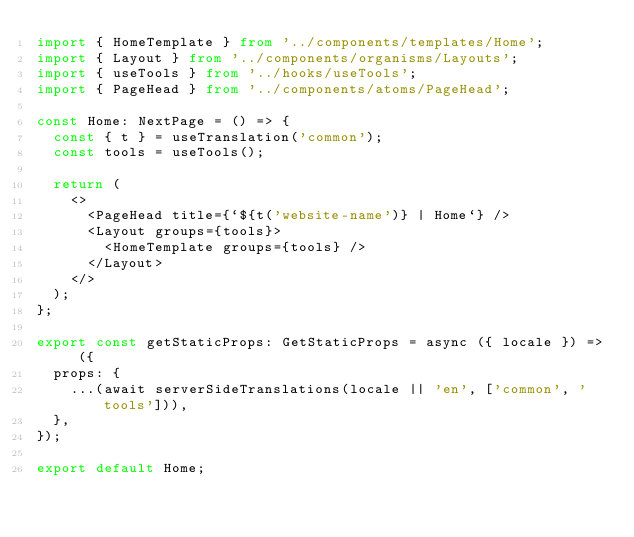<code> <loc_0><loc_0><loc_500><loc_500><_TypeScript_>import { HomeTemplate } from '../components/templates/Home';
import { Layout } from '../components/organisms/Layouts';
import { useTools } from '../hooks/useTools';
import { PageHead } from '../components/atoms/PageHead';

const Home: NextPage = () => {
  const { t } = useTranslation('common');
  const tools = useTools();

  return (
    <>
      <PageHead title={`${t('website-name')} | Home`} />
      <Layout groups={tools}>
        <HomeTemplate groups={tools} />
      </Layout>
    </>
  );
};

export const getStaticProps: GetStaticProps = async ({ locale }) => ({
  props: {
    ...(await serverSideTranslations(locale || 'en', ['common', 'tools'])),
  },
});

export default Home;
</code> 